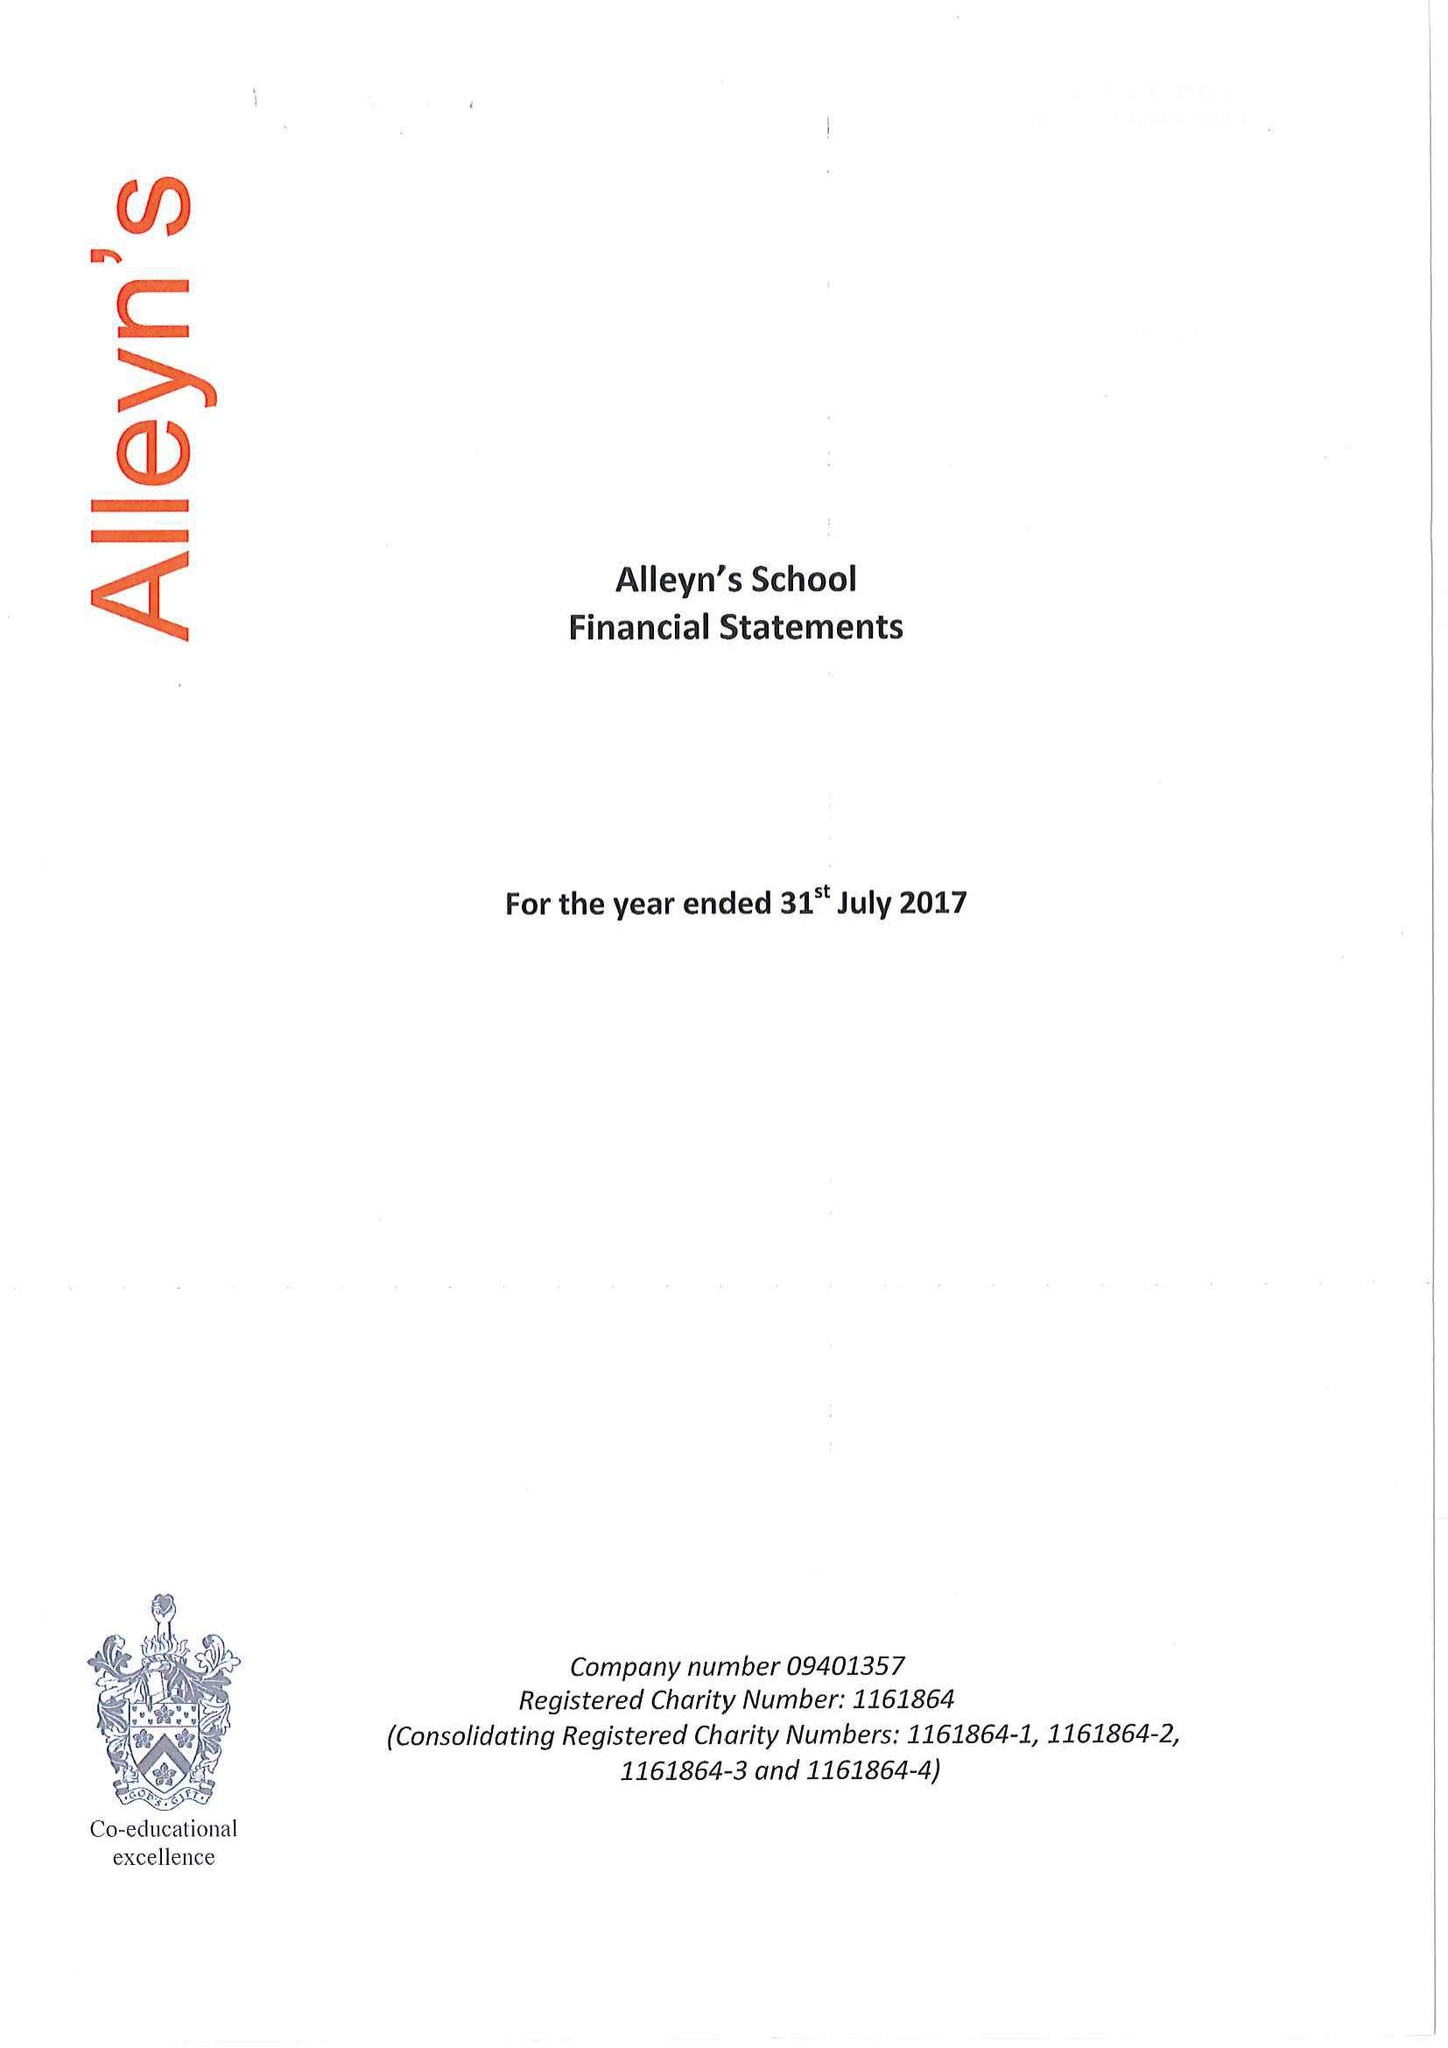What is the value for the address__street_line?
Answer the question using a single word or phrase. TOWNLEY ROAD 